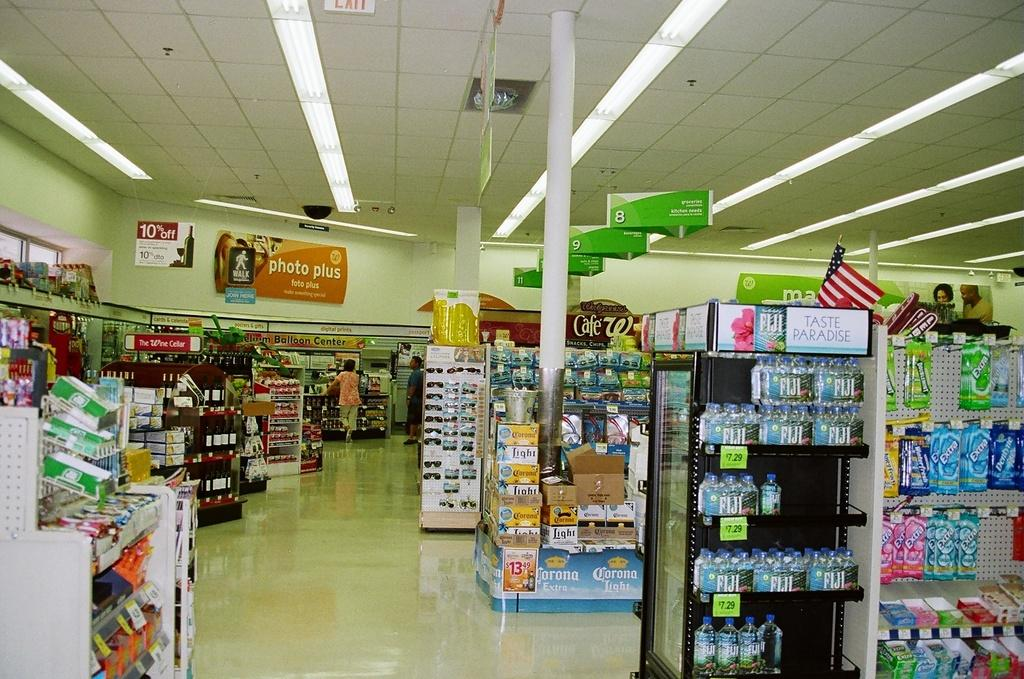Provide a one-sentence caption for the provided image. A few customers are visible by the photo area of a drugstore. 